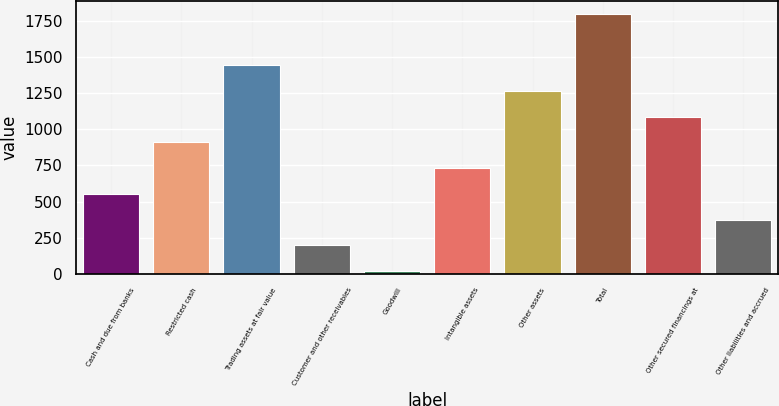Convert chart. <chart><loc_0><loc_0><loc_500><loc_500><bar_chart><fcel>Cash and due from banks<fcel>Restricted cash<fcel>Trading assets at fair value<fcel>Customer and other receivables<fcel>Goodwill<fcel>Intangible assets<fcel>Other assets<fcel>Total<fcel>Other secured financings at<fcel>Other liabilities and accrued<nl><fcel>552.9<fcel>909.5<fcel>1444.4<fcel>196.3<fcel>18<fcel>731.2<fcel>1266.1<fcel>1801<fcel>1087.8<fcel>374.6<nl></chart> 